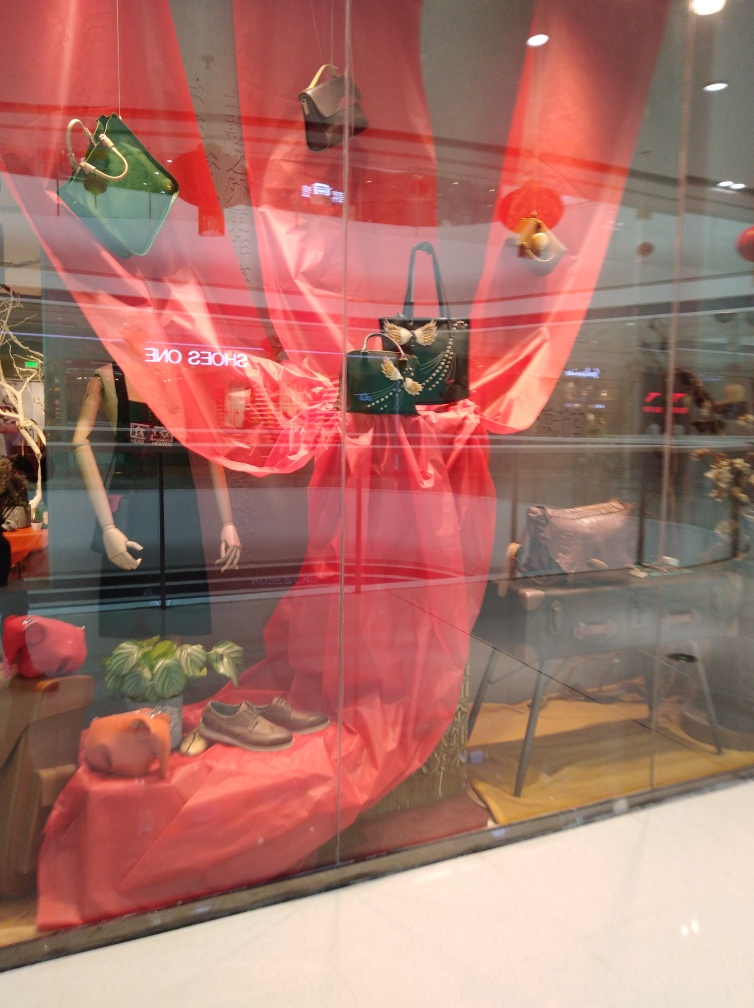How is the lighting affecting the appearance of the items inside the display window? The lighting seems to be coming from outside the display window, contributing to the reflections on the glass. This external light source highlights the textures and colors of the bags and accessories, creating a dynamic contrast between light and shadow that makes the display visually appealing. What can you tell me about the items being displayed? The items on display are a collection of fashion accessories, including a variety of handbags in different shapes and sizes, possibly targeting a style-conscious audience. There's also a pair of brown shoes and some foliage, which seem to add an organic touch to the arrangement, suggesting a theme or seasonal collection. 